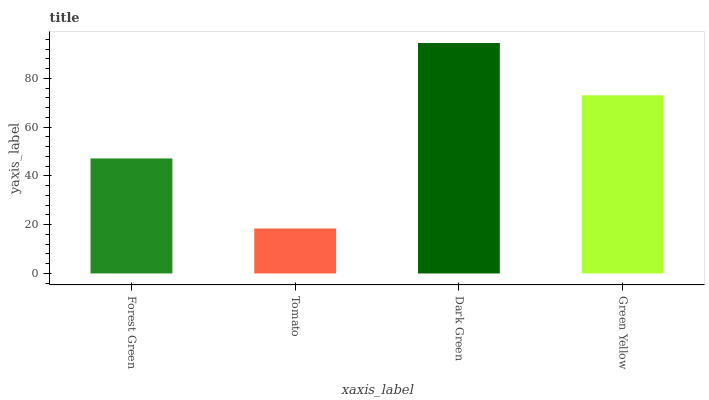Is Tomato the minimum?
Answer yes or no. Yes. Is Dark Green the maximum?
Answer yes or no. Yes. Is Dark Green the minimum?
Answer yes or no. No. Is Tomato the maximum?
Answer yes or no. No. Is Dark Green greater than Tomato?
Answer yes or no. Yes. Is Tomato less than Dark Green?
Answer yes or no. Yes. Is Tomato greater than Dark Green?
Answer yes or no. No. Is Dark Green less than Tomato?
Answer yes or no. No. Is Green Yellow the high median?
Answer yes or no. Yes. Is Forest Green the low median?
Answer yes or no. Yes. Is Dark Green the high median?
Answer yes or no. No. Is Green Yellow the low median?
Answer yes or no. No. 